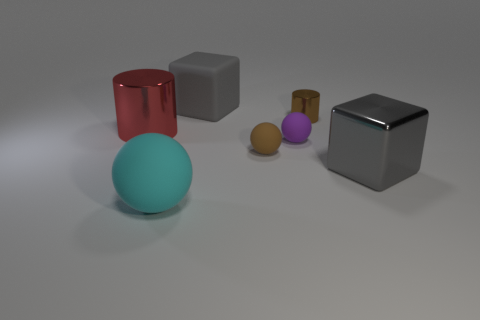Subtract all cyan balls. Subtract all blue cylinders. How many balls are left? 2 Add 2 brown matte objects. How many objects exist? 9 Subtract all cylinders. How many objects are left? 5 Add 6 rubber balls. How many rubber balls are left? 9 Add 2 purple spheres. How many purple spheres exist? 3 Subtract 1 gray cubes. How many objects are left? 6 Subtract all shiny cylinders. Subtract all big metallic things. How many objects are left? 3 